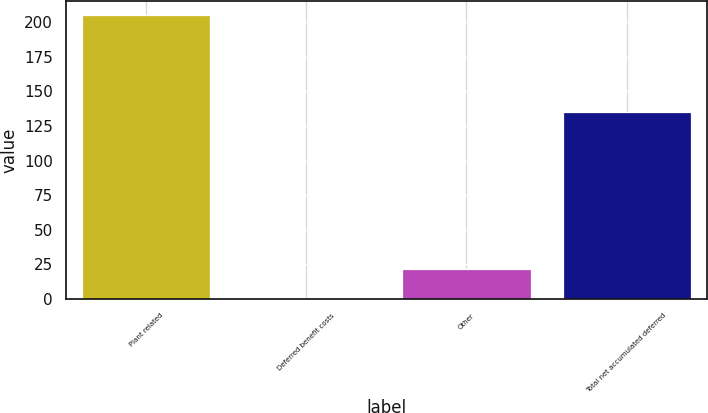Convert chart to OTSL. <chart><loc_0><loc_0><loc_500><loc_500><bar_chart><fcel>Plant related<fcel>Deferred benefit costs<fcel>Other<fcel>Total net accumulated deferred<nl><fcel>205<fcel>1<fcel>21.4<fcel>135<nl></chart> 